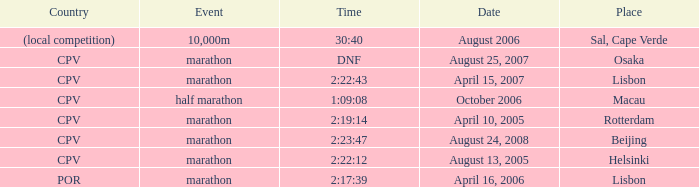Where is the half marathon event held, in terms of country? CPV. 